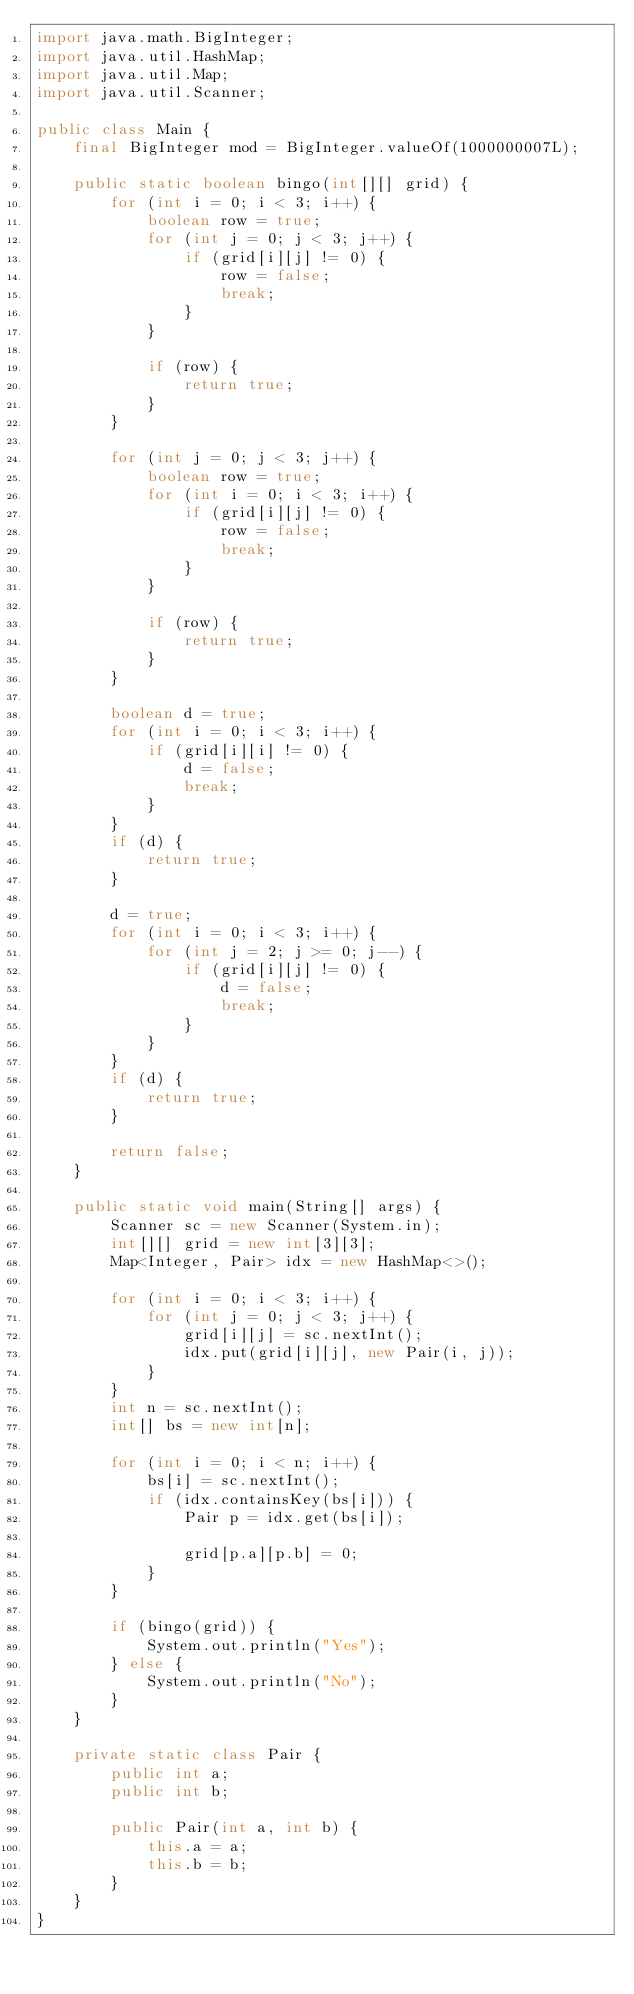Convert code to text. <code><loc_0><loc_0><loc_500><loc_500><_Java_>import java.math.BigInteger;
import java.util.HashMap;
import java.util.Map;
import java.util.Scanner;

public class Main {
    final BigInteger mod = BigInteger.valueOf(1000000007L);

    public static boolean bingo(int[][] grid) {
        for (int i = 0; i < 3; i++) {
            boolean row = true;
            for (int j = 0; j < 3; j++) {
                if (grid[i][j] != 0) {
                    row = false;
                    break;
                }
            }

            if (row) {
                return true;
            }
        }

        for (int j = 0; j < 3; j++) {
            boolean row = true;
            for (int i = 0; i < 3; i++) {
                if (grid[i][j] != 0) {
                    row = false;
                    break;
                }
            }

            if (row) {
                return true;
            }
        }

        boolean d = true;
        for (int i = 0; i < 3; i++) {
            if (grid[i][i] != 0) {
                d = false;
                break;
            }
        }
        if (d) {
            return true;
        }

        d = true;
        for (int i = 0; i < 3; i++) {
            for (int j = 2; j >= 0; j--) {
                if (grid[i][j] != 0) {
                    d = false;
                    break;
                }
            }
        }
        if (d) {
            return true;
        }

        return false;
    }

    public static void main(String[] args) {
        Scanner sc = new Scanner(System.in);
        int[][] grid = new int[3][3];
        Map<Integer, Pair> idx = new HashMap<>();

        for (int i = 0; i < 3; i++) {
            for (int j = 0; j < 3; j++) {
                grid[i][j] = sc.nextInt();
                idx.put(grid[i][j], new Pair(i, j));
            }
        }
        int n = sc.nextInt();
        int[] bs = new int[n];

        for (int i = 0; i < n; i++) {
            bs[i] = sc.nextInt();
            if (idx.containsKey(bs[i])) {
                Pair p = idx.get(bs[i]);

                grid[p.a][p.b] = 0;
            }
        }

        if (bingo(grid)) {
            System.out.println("Yes");
        } else {
            System.out.println("No");
        }
    }

    private static class Pair {
        public int a;
        public int b;

        public Pair(int a, int b) {
            this.a = a;
            this.b = b;
        }
    }
}</code> 